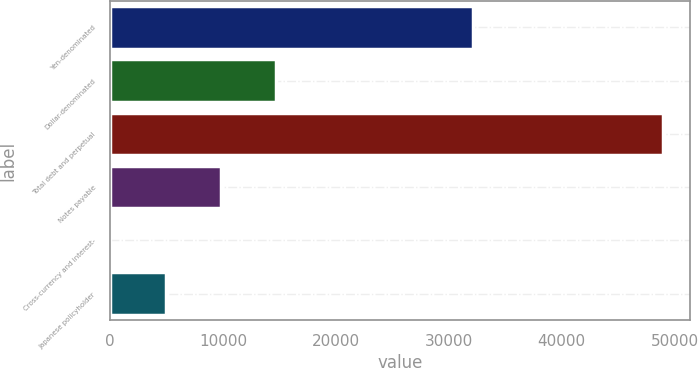<chart> <loc_0><loc_0><loc_500><loc_500><bar_chart><fcel>Yen-denominated<fcel>Dollar-denominated<fcel>Total debt and perpetual<fcel>Notes payable<fcel>Cross-currency and interest-<fcel>Japanese policyholder<nl><fcel>32151<fcel>14700.9<fcel>48940<fcel>9809.6<fcel>27<fcel>4918.3<nl></chart> 